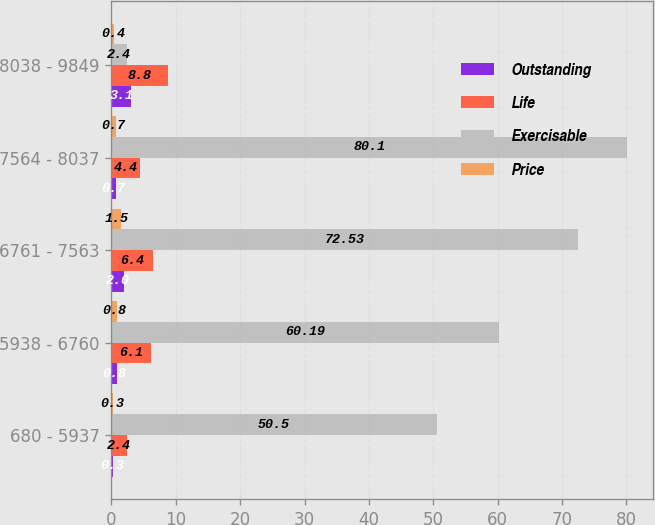Convert chart. <chart><loc_0><loc_0><loc_500><loc_500><stacked_bar_chart><ecel><fcel>680 - 5937<fcel>5938 - 6760<fcel>6761 - 7563<fcel>7564 - 8037<fcel>8038 - 9849<nl><fcel>Outstanding<fcel>0.3<fcel>0.8<fcel>2<fcel>0.7<fcel>3.1<nl><fcel>Life<fcel>2.4<fcel>6.1<fcel>6.4<fcel>4.4<fcel>8.8<nl><fcel>Exercisable<fcel>50.5<fcel>60.19<fcel>72.53<fcel>80.1<fcel>2.4<nl><fcel>Price<fcel>0.3<fcel>0.8<fcel>1.5<fcel>0.7<fcel>0.4<nl></chart> 